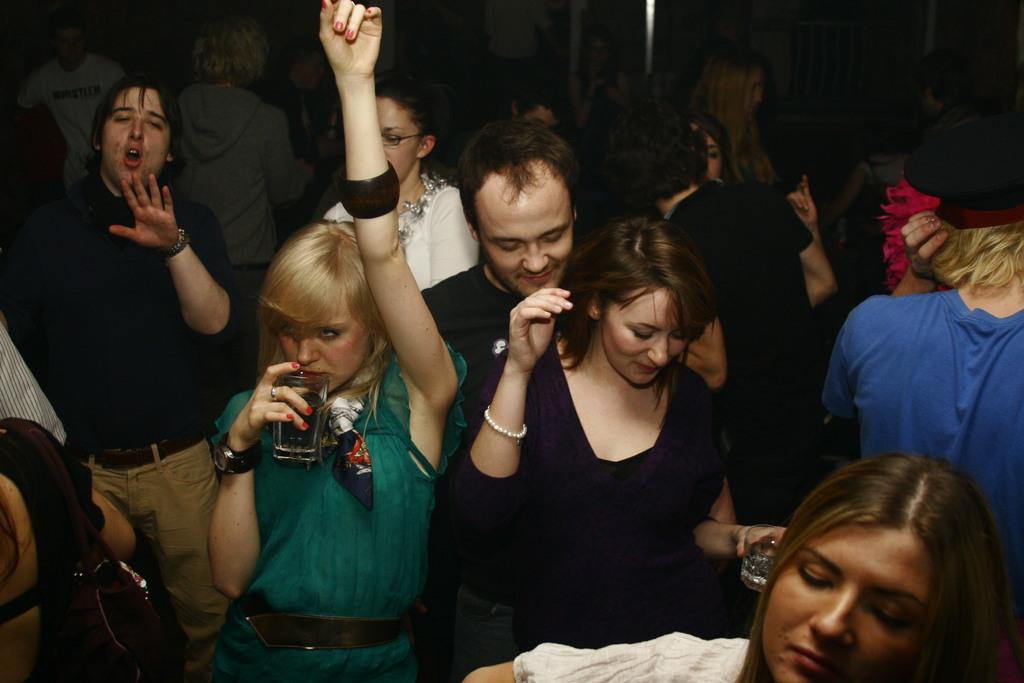What types of people are present in the image? There are men and women in the image. Where are the people located? The people are standing on the floor. What are the people doing in the image? The people are dancing. What objects are some people holding in their hands? Some people are carrying glasses in their hands. What expressions can be seen on the faces of the people? Some people are smiling. What type of cracker is being passed around in the image? There is no cracker present in the image. How many pizzas are visible on the table in the image? There are no pizzas visible in the image. 